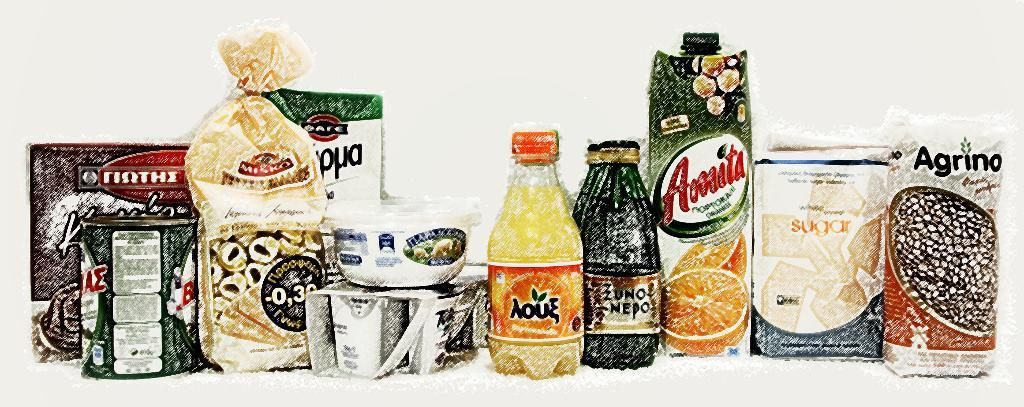<image>
Render a clear and concise summary of the photo. several food items are lined up, including a container of Amita 